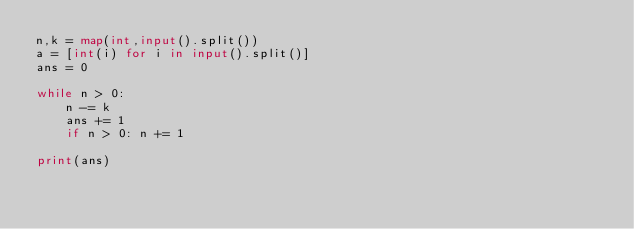<code> <loc_0><loc_0><loc_500><loc_500><_Python_>n,k = map(int,input().split())
a = [int(i) for i in input().split()]
ans = 0

while n > 0:
    n -= k
    ans += 1
    if n > 0: n += 1

print(ans)</code> 